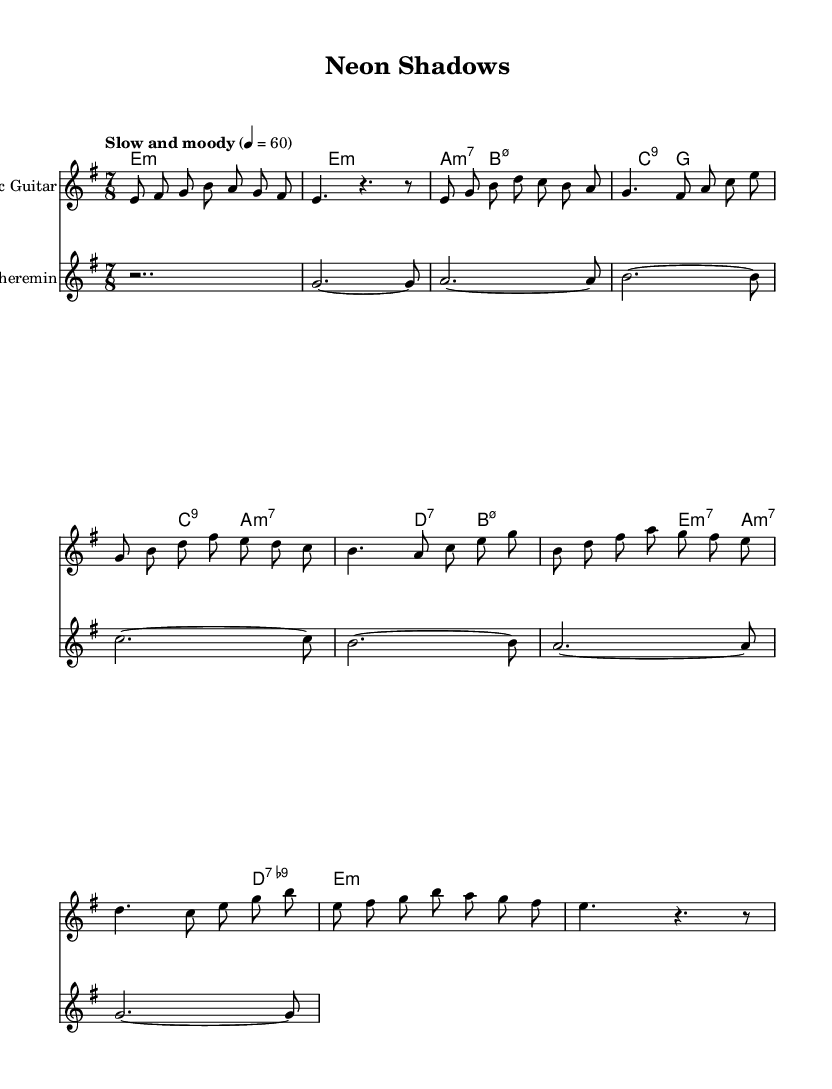What is the key signature of this music? The key signature is E minor, which includes one sharp (F#). This can be determined by looking at the key specified in the global settings of the sheet music.
Answer: E minor What is the time signature of this piece? The time signature is 7/8, as indicated in the global settings of the sheet music. This means there are seven eighth-note beats in each measure.
Answer: 7/8 What is the tempo indication given for the piece? The tempo indication states "Slow and moody", with a metronome marking of 60 beats per minute. This is found in the global settings and indicates how fast the music should be played.
Answer: Slow and moody What type of instrument is featured along with the electric guitar? The theremin is the unconventional instrument featured alongside the electric guitar. It is specified in the score sections of the sheet music.
Answer: Theremin How many measures are included in the electric guitar part? The electric guitar part consists of eight measures, as indicated by the notation present in the score. Counting the measures visually confirms this number.
Answer: Eight What harmonic chord is played during the intro? The harmonic chord played during the intro is E minor, as specified in the chord mode section of the sheet music. This can be verified by looking for the chord indications in the harmony section.
Answer: E minor Is there a bridge section in this piece? Yes, there is a bridge section present, as denoted by the labels in the electric guitar part. This section typically contrasts with the verse and chorus, adding variety to the composition.
Answer: Yes 